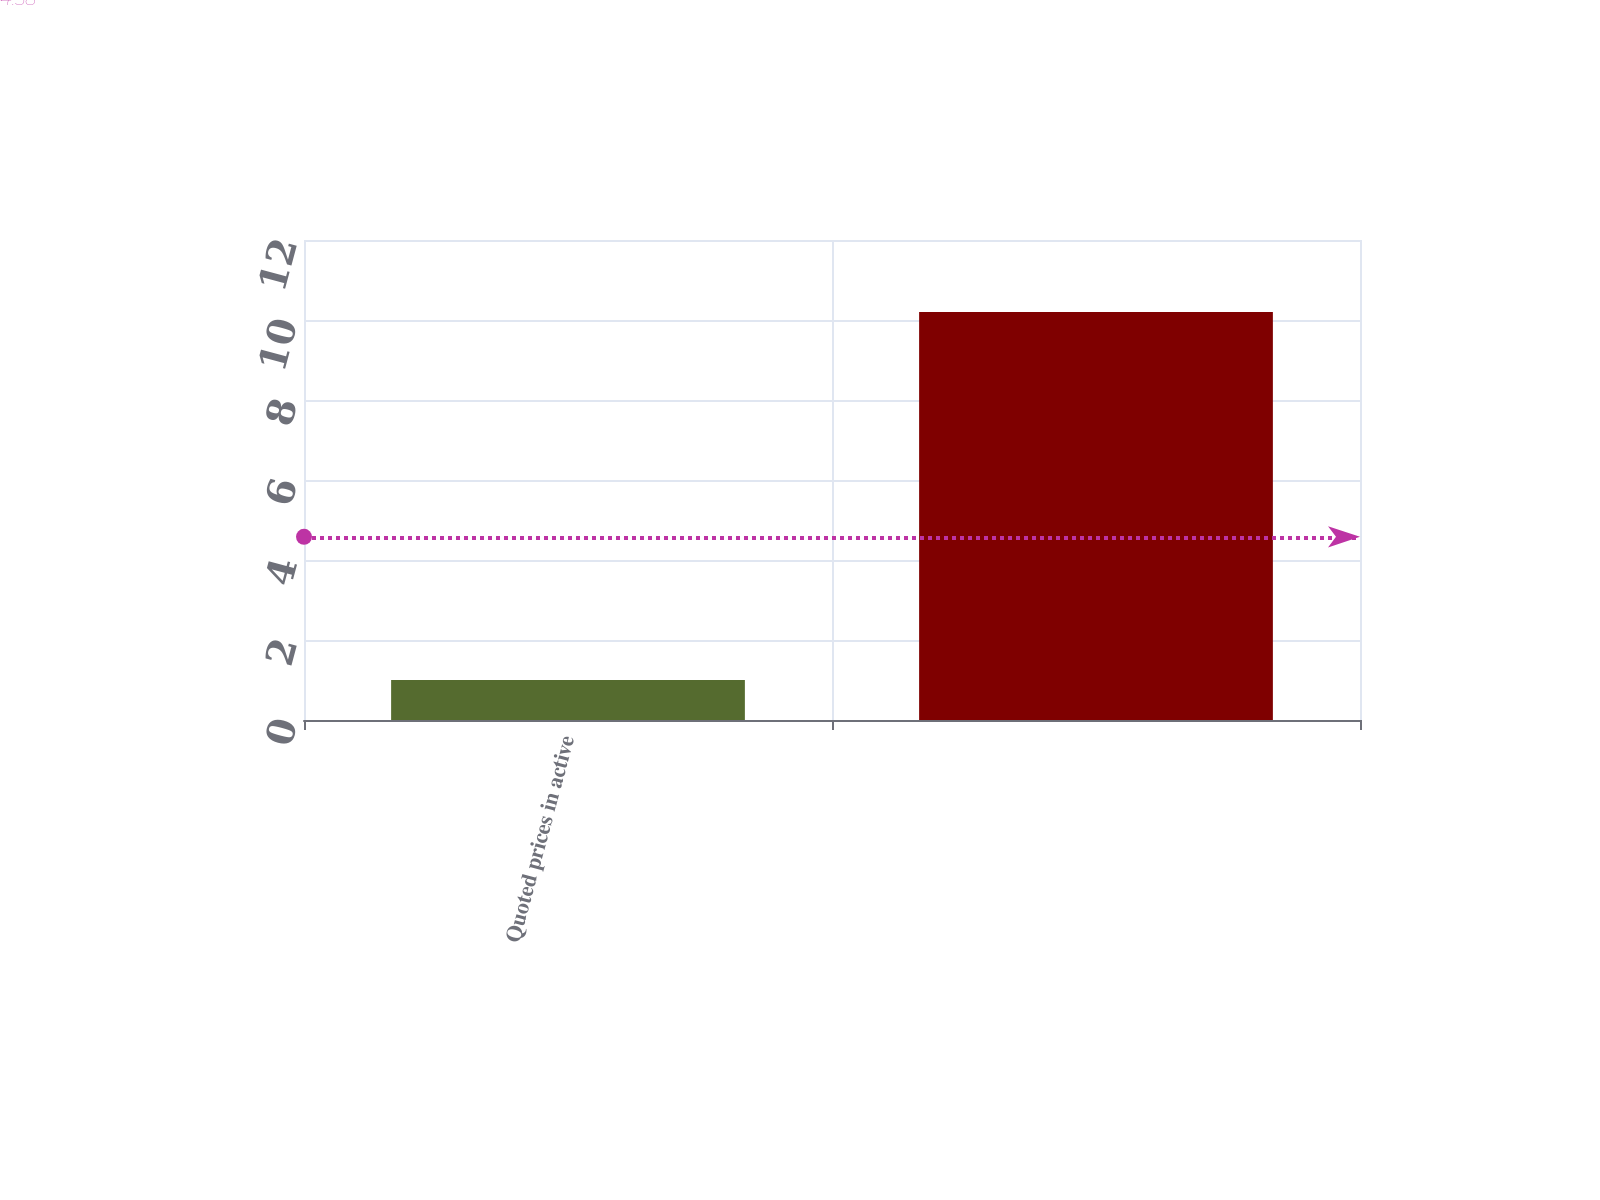Convert chart. <chart><loc_0><loc_0><loc_500><loc_500><bar_chart><fcel>Quoted prices in active<fcel>Unnamed: 1<nl><fcel>1<fcel>10.2<nl></chart> 